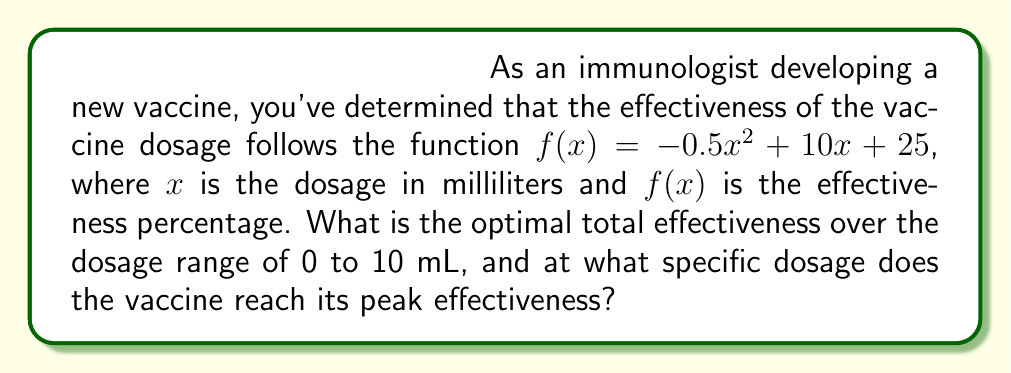Can you answer this question? To solve this problem, we'll follow these steps:

1. Find the total effectiveness by integrating the function over the given range:
   $$\int_0^{10} f(x) dx = \int_0^{10} (-0.5x^2 + 10x + 25) dx$$

2. Integrate the function:
   $$\left[-\frac{1}{6}x^3 + 5x^2 + 25x\right]_0^{10}$$

3. Evaluate the integral:
   $$\left(-\frac{1000}{6} + 500 + 250\right) - (0) = 583.33$$

4. To find the peak effectiveness, we need to find the maximum of $f(x)$:
   Take the derivative: $f'(x) = -x + 10$
   Set $f'(x) = 0$: $-x + 10 = 0$
   Solve for $x$: $x = 10$

5. Verify it's a maximum by checking the second derivative:
   $f''(x) = -1 < 0$, confirming it's a maximum

6. Calculate the peak effectiveness:
   $f(10) = -0.5(10)^2 + 10(10) + 25 = 75$

The optimal total effectiveness is 583.33 percentage-units (area under the curve), and the peak effectiveness of 75% occurs at a dosage of 10 mL.
Answer: 583.33 percentage-units; 10 mL 